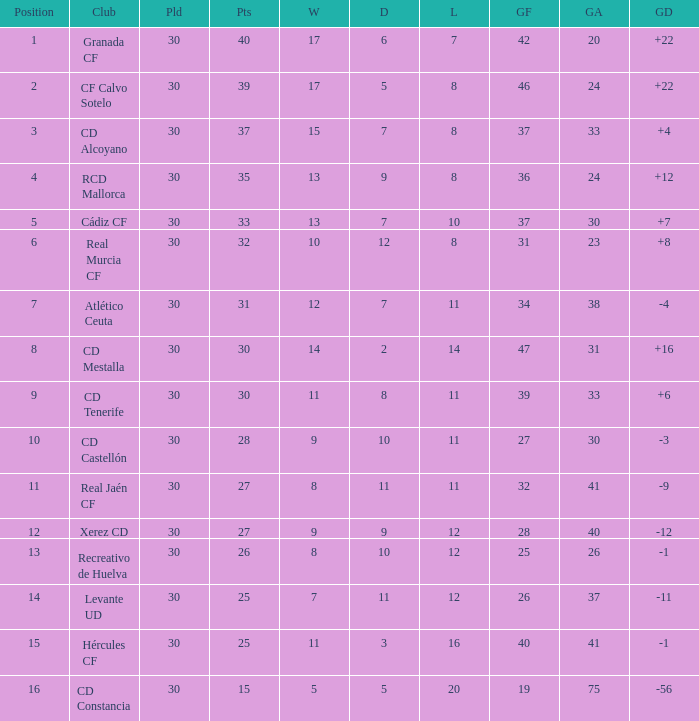How many Draws have 30 Points, and less than 33 Goals against? 1.0. 